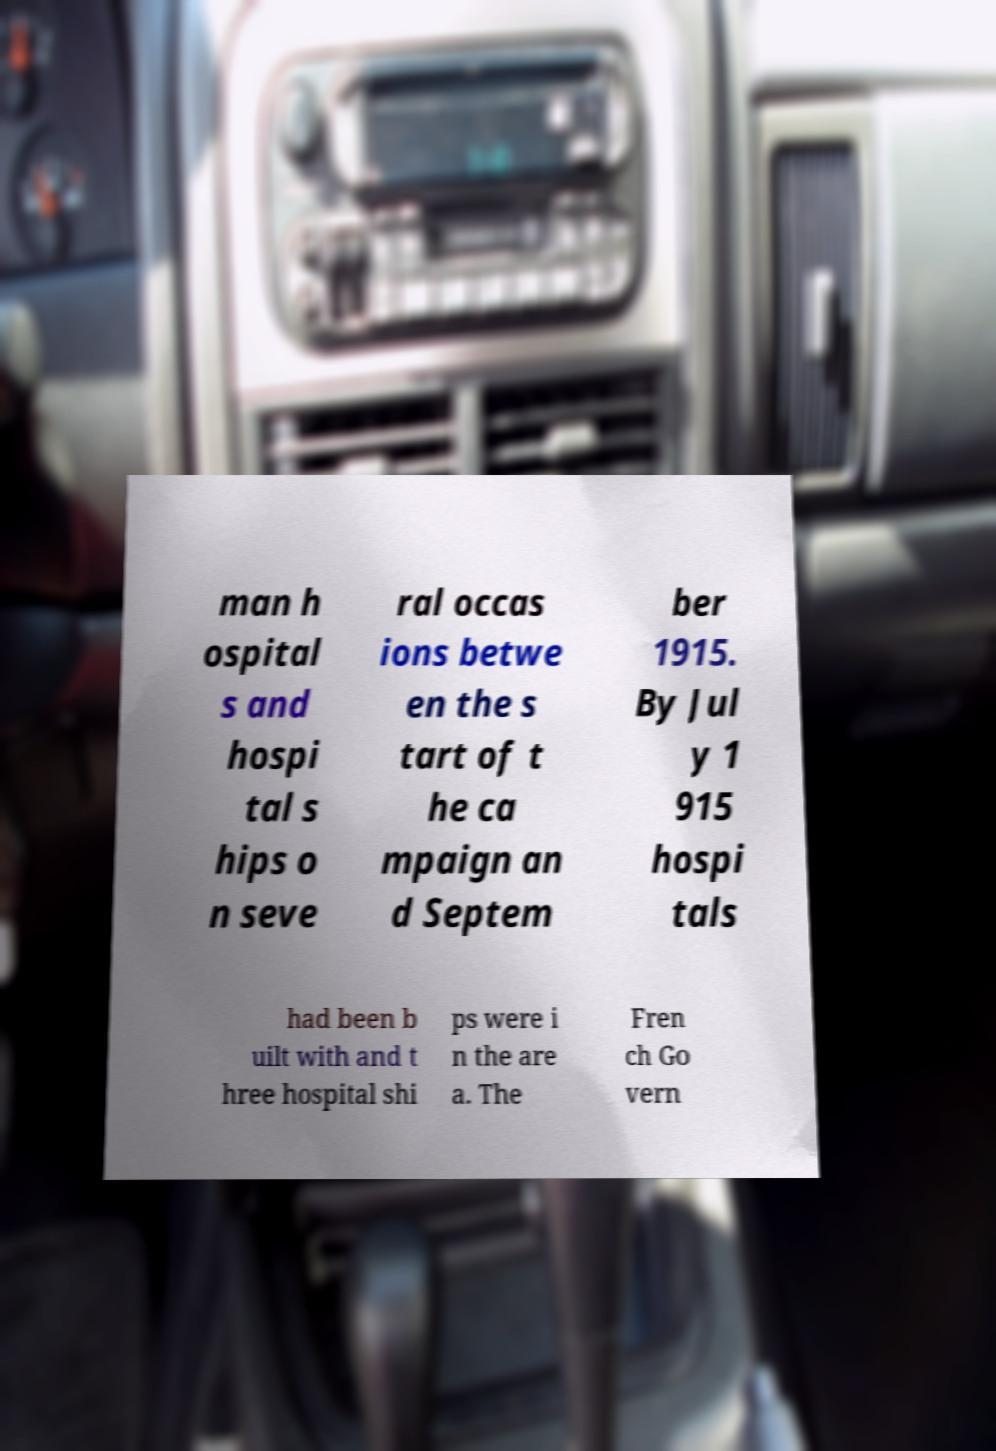Could you assist in decoding the text presented in this image and type it out clearly? man h ospital s and hospi tal s hips o n seve ral occas ions betwe en the s tart of t he ca mpaign an d Septem ber 1915. By Jul y 1 915 hospi tals had been b uilt with and t hree hospital shi ps were i n the are a. The Fren ch Go vern 